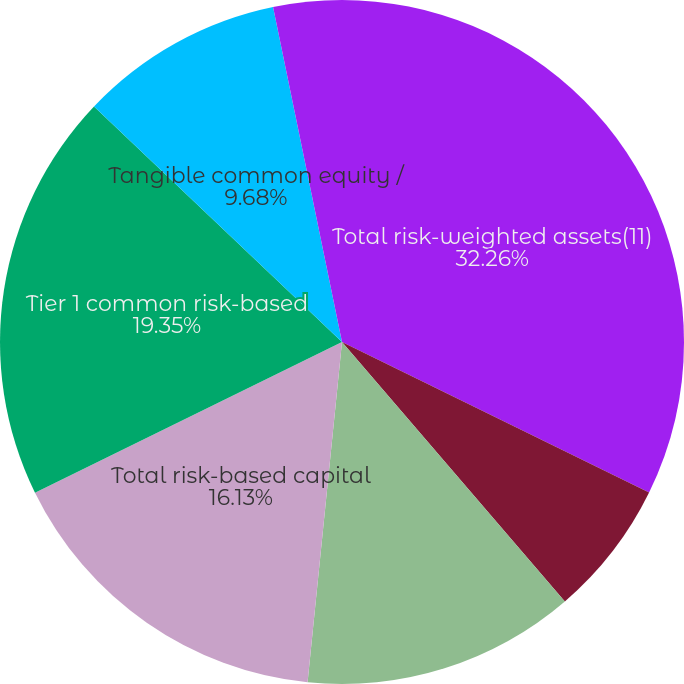<chart> <loc_0><loc_0><loc_500><loc_500><pie_chart><fcel>Total risk-weighted assets(11)<fcel>Tier 1 leverage ratio(11)<fcel>Tier 1 risk-based capital<fcel>Total risk-based capital<fcel>Tier 1 common risk-based<fcel>Tangible common equity /<fcel>Tangible equity / tangible<nl><fcel>32.25%<fcel>6.45%<fcel>12.9%<fcel>16.13%<fcel>19.35%<fcel>9.68%<fcel>3.23%<nl></chart> 